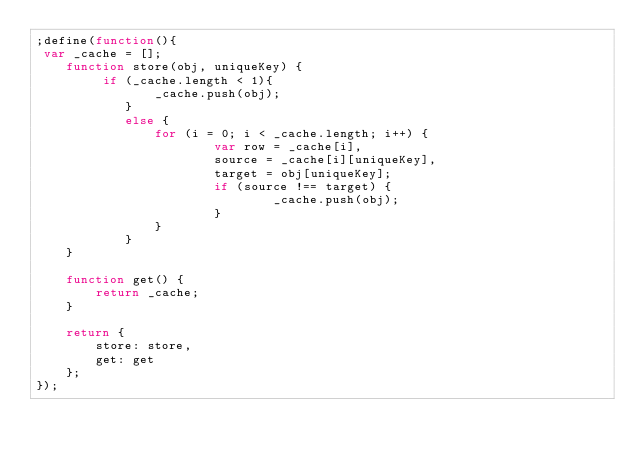<code> <loc_0><loc_0><loc_500><loc_500><_JavaScript_>;define(function(){
 var _cache = [];
    function store(obj, uniqueKey) {
         if (_cache.length < 1){
                _cache.push(obj);
            }
            else {
                for (i = 0; i < _cache.length; i++) {
                        var row = _cache[i],
                        source = _cache[i][uniqueKey],
                        target = obj[uniqueKey];
                        if (source !== target) {
                                _cache.push(obj);
                        }
                }
            }
    }

    function get() {
        return _cache;
    }

    return {
        store: store,
        get: get
    };
});</code> 